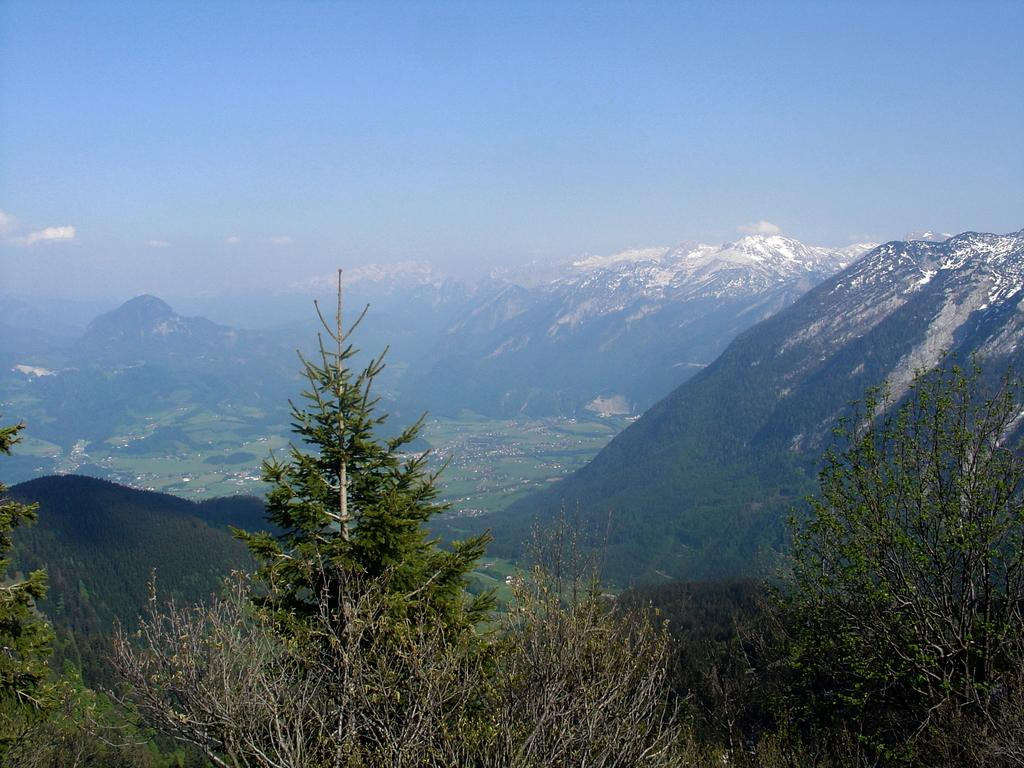What is the main feature in the center of the image? The center of the image contains the sky. What can be seen in the sky? Clouds are visible in the sky. What type of landscape features are present in the image? Hills and trees are visible in the image. What type of vegetation is present in the image? Grass is present in the image. What advice is the grass giving to the trees in the image? There is no indication in the image that the grass is giving advice to the trees, as plants do not communicate in this manner. 